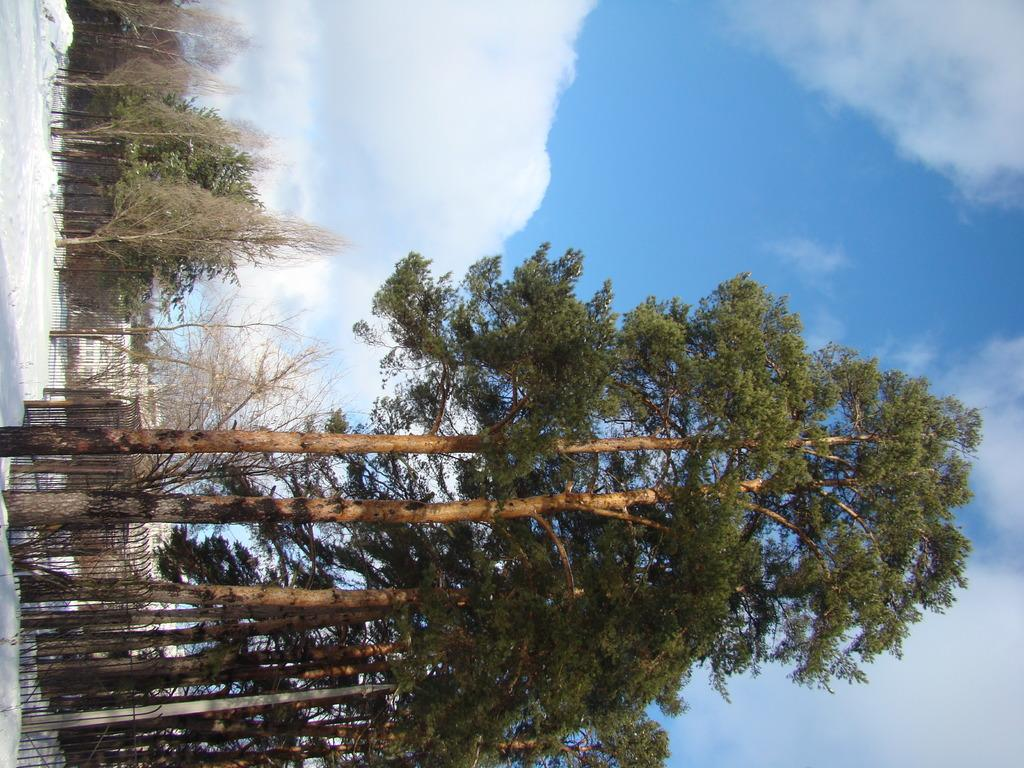What type of vegetation can be seen in the image? There are trees in the image. What is separating the trees from another area in the image? There is a fence in the image. What is covering the ground in the image? The ground is covered in snow. What part of the natural environment is visible in the image? The sky is visible in the image. What can be seen in the sky in the image? Clouds are present in the sky. What type of pencil can be seen drawing on the trees in the image? There is no pencil present in the image, and the trees are not being drawn on. What type of attack is happening to the trees in the image? There is no attack happening to the trees in the image; they are simply standing in the snowy landscape. 